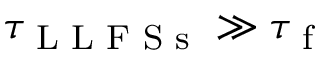<formula> <loc_0><loc_0><loc_500><loc_500>\tau _ { L L F S s } \gg \tau _ { f }</formula> 